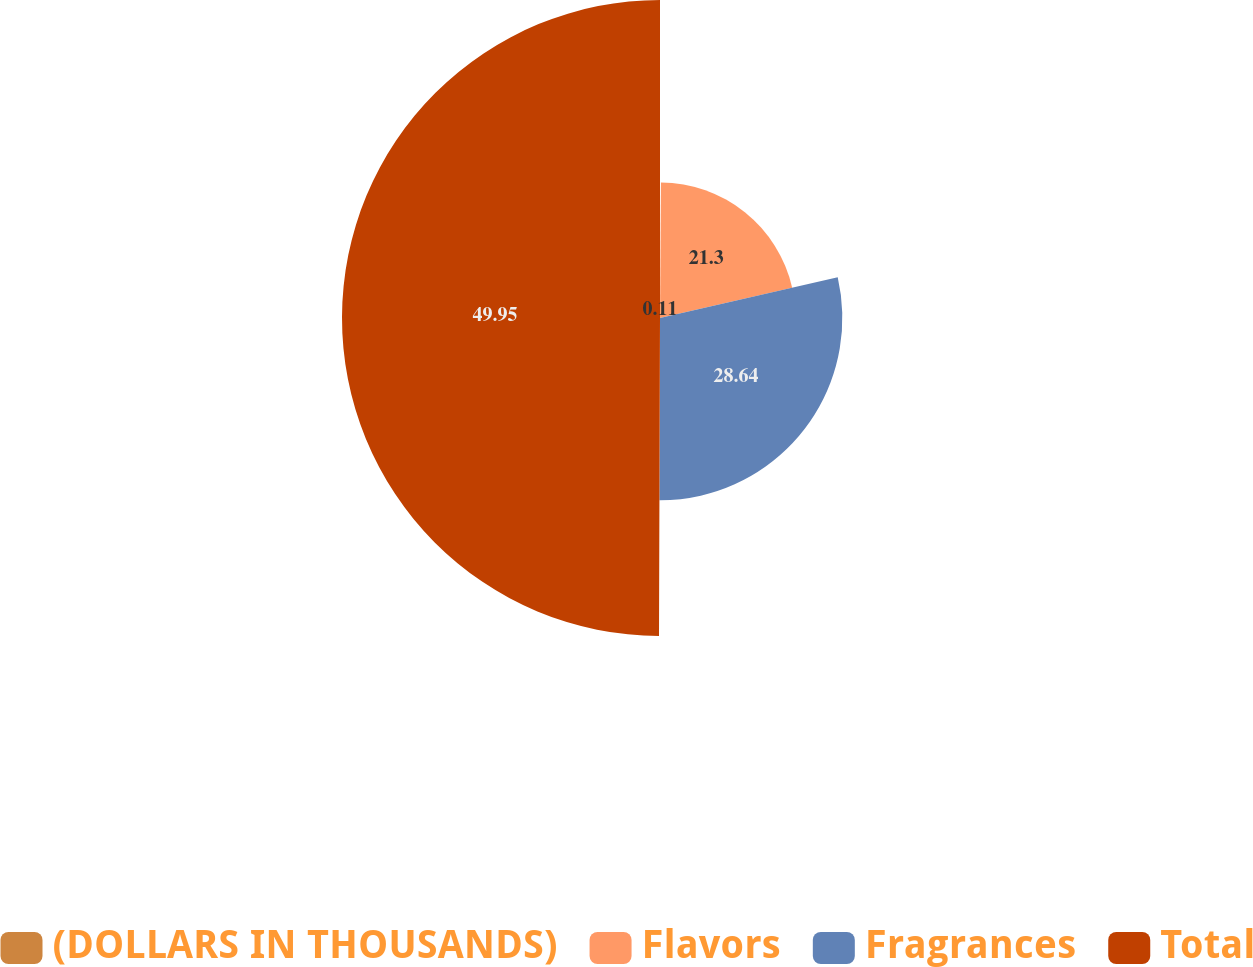Convert chart. <chart><loc_0><loc_0><loc_500><loc_500><pie_chart><fcel>(DOLLARS IN THOUSANDS)<fcel>Flavors<fcel>Fragrances<fcel>Total<nl><fcel>0.11%<fcel>21.3%<fcel>28.64%<fcel>49.95%<nl></chart> 